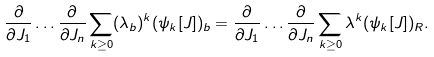Convert formula to latex. <formula><loc_0><loc_0><loc_500><loc_500>\frac { \partial } { \partial J _ { 1 } } \dots \frac { \partial } { \partial J _ { n } } \sum _ { k \geq 0 } ( \lambda _ { b } ) ^ { k } ( \psi _ { k } [ J ] ) _ { b } = \frac { \partial } { \partial J _ { 1 } } \dots \frac { \partial } { \partial J _ { n } } \sum _ { k \geq 0 } \lambda ^ { k } ( \psi _ { k } [ J ] ) _ { R } .</formula> 